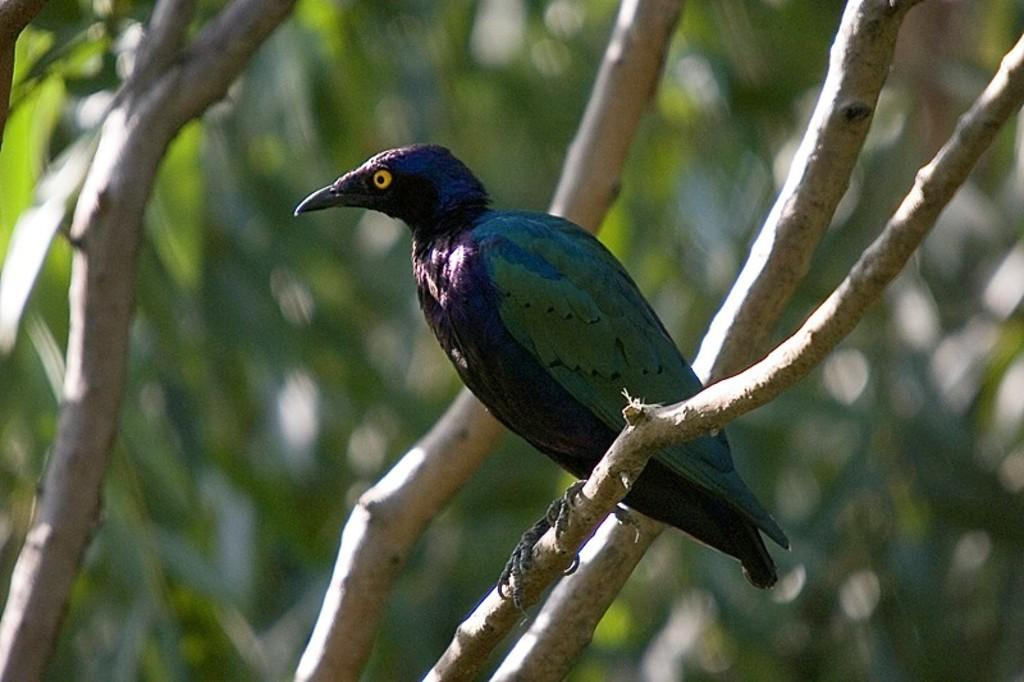What type of animal can be seen in the image? There is a bird in the image. Where is the bird located in the image? The bird is on the branch of a tree. What type of knee can be seen on the bird in the image? Birds do not have knees like humans; they have a different type of leg structure. Therefore, there are no visible knees on the bird in the image. 